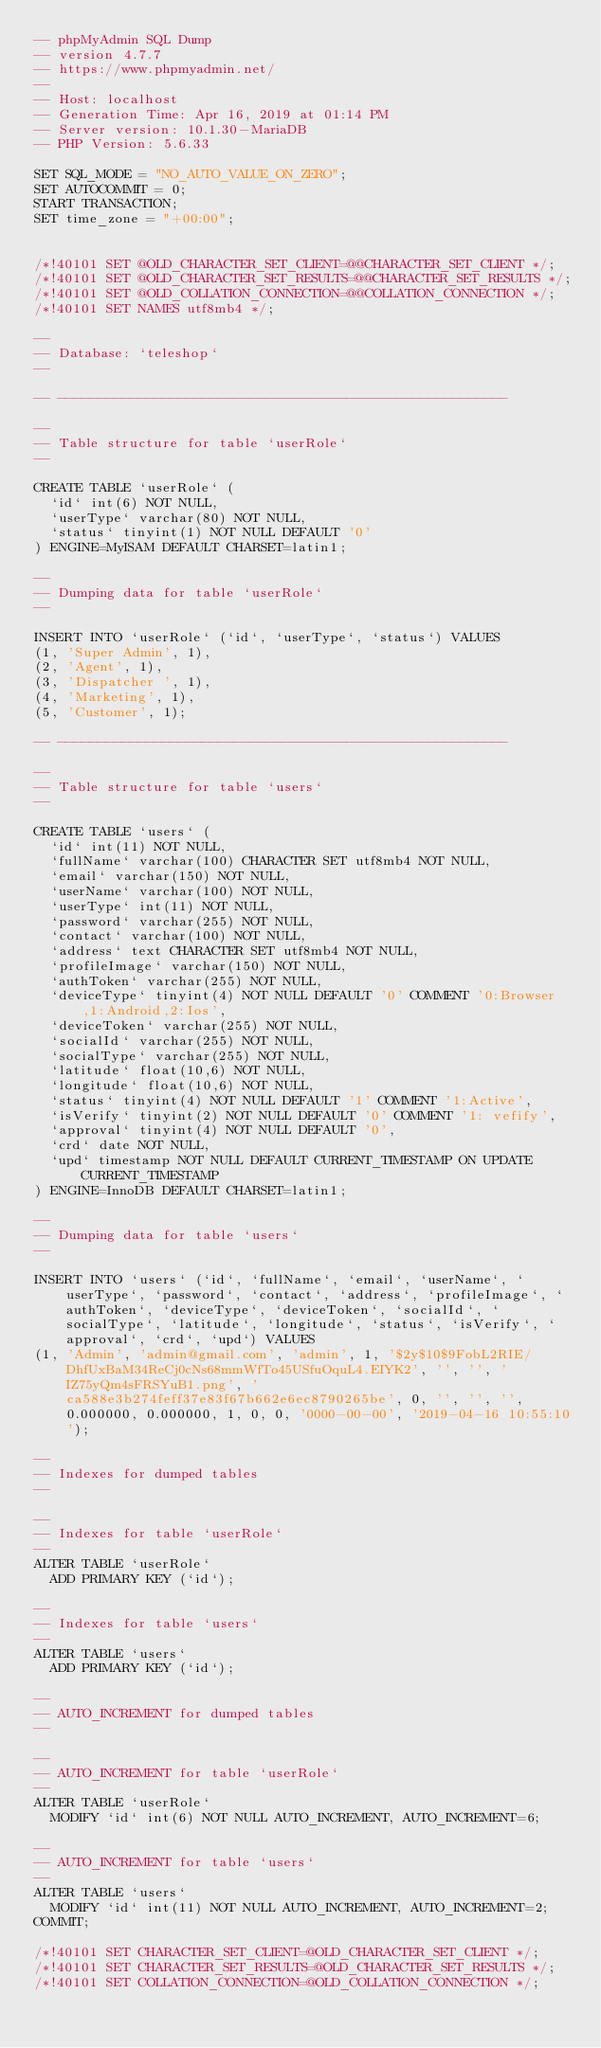<code> <loc_0><loc_0><loc_500><loc_500><_SQL_>-- phpMyAdmin SQL Dump
-- version 4.7.7
-- https://www.phpmyadmin.net/
--
-- Host: localhost
-- Generation Time: Apr 16, 2019 at 01:14 PM
-- Server version: 10.1.30-MariaDB
-- PHP Version: 5.6.33

SET SQL_MODE = "NO_AUTO_VALUE_ON_ZERO";
SET AUTOCOMMIT = 0;
START TRANSACTION;
SET time_zone = "+00:00";


/*!40101 SET @OLD_CHARACTER_SET_CLIENT=@@CHARACTER_SET_CLIENT */;
/*!40101 SET @OLD_CHARACTER_SET_RESULTS=@@CHARACTER_SET_RESULTS */;
/*!40101 SET @OLD_COLLATION_CONNECTION=@@COLLATION_CONNECTION */;
/*!40101 SET NAMES utf8mb4 */;

--
-- Database: `teleshop`
--

-- --------------------------------------------------------

--
-- Table structure for table `userRole`
--

CREATE TABLE `userRole` (
  `id` int(6) NOT NULL,
  `userType` varchar(80) NOT NULL,
  `status` tinyint(1) NOT NULL DEFAULT '0'
) ENGINE=MyISAM DEFAULT CHARSET=latin1;

--
-- Dumping data for table `userRole`
--

INSERT INTO `userRole` (`id`, `userType`, `status`) VALUES
(1, 'Super Admin', 1),
(2, 'Agent', 1),
(3, 'Dispatcher ', 1),
(4, 'Marketing', 1),
(5, 'Customer', 1);

-- --------------------------------------------------------

--
-- Table structure for table `users`
--

CREATE TABLE `users` (
  `id` int(11) NOT NULL,
  `fullName` varchar(100) CHARACTER SET utf8mb4 NOT NULL,
  `email` varchar(150) NOT NULL,
  `userName` varchar(100) NOT NULL,
  `userType` int(11) NOT NULL,
  `password` varchar(255) NOT NULL,
  `contact` varchar(100) NOT NULL,
  `address` text CHARACTER SET utf8mb4 NOT NULL,
  `profileImage` varchar(150) NOT NULL,
  `authToken` varchar(255) NOT NULL,
  `deviceType` tinyint(4) NOT NULL DEFAULT '0' COMMENT '0:Browser,1:Android,2:Ios',
  `deviceToken` varchar(255) NOT NULL,
  `socialId` varchar(255) NOT NULL,
  `socialType` varchar(255) NOT NULL,
  `latitude` float(10,6) NOT NULL,
  `longitude` float(10,6) NOT NULL,
  `status` tinyint(4) NOT NULL DEFAULT '1' COMMENT '1:Active',
  `isVerify` tinyint(2) NOT NULL DEFAULT '0' COMMENT '1: vefify',
  `approval` tinyint(4) NOT NULL DEFAULT '0',
  `crd` date NOT NULL,
  `upd` timestamp NOT NULL DEFAULT CURRENT_TIMESTAMP ON UPDATE CURRENT_TIMESTAMP
) ENGINE=InnoDB DEFAULT CHARSET=latin1;

--
-- Dumping data for table `users`
--

INSERT INTO `users` (`id`, `fullName`, `email`, `userName`, `userType`, `password`, `contact`, `address`, `profileImage`, `authToken`, `deviceType`, `deviceToken`, `socialId`, `socialType`, `latitude`, `longitude`, `status`, `isVerify`, `approval`, `crd`, `upd`) VALUES
(1, 'Admin', 'admin@gmail.com', 'admin', 1, '$2y$10$9FobL2RIE/DhfUxBaM34ReCj0cNs68mmWfTo45USfuOquL4.EIYK2', '', '', 'IZ75yQm4sFRSYuB1.png', 'ca588e3b274feff37e83f67b662e6ec8790265be', 0, '', '', '', 0.000000, 0.000000, 1, 0, 0, '0000-00-00', '2019-04-16 10:55:10');

--
-- Indexes for dumped tables
--

--
-- Indexes for table `userRole`
--
ALTER TABLE `userRole`
  ADD PRIMARY KEY (`id`);

--
-- Indexes for table `users`
--
ALTER TABLE `users`
  ADD PRIMARY KEY (`id`);

--
-- AUTO_INCREMENT for dumped tables
--

--
-- AUTO_INCREMENT for table `userRole`
--
ALTER TABLE `userRole`
  MODIFY `id` int(6) NOT NULL AUTO_INCREMENT, AUTO_INCREMENT=6;

--
-- AUTO_INCREMENT for table `users`
--
ALTER TABLE `users`
  MODIFY `id` int(11) NOT NULL AUTO_INCREMENT, AUTO_INCREMENT=2;
COMMIT;

/*!40101 SET CHARACTER_SET_CLIENT=@OLD_CHARACTER_SET_CLIENT */;
/*!40101 SET CHARACTER_SET_RESULTS=@OLD_CHARACTER_SET_RESULTS */;
/*!40101 SET COLLATION_CONNECTION=@OLD_COLLATION_CONNECTION */;
</code> 